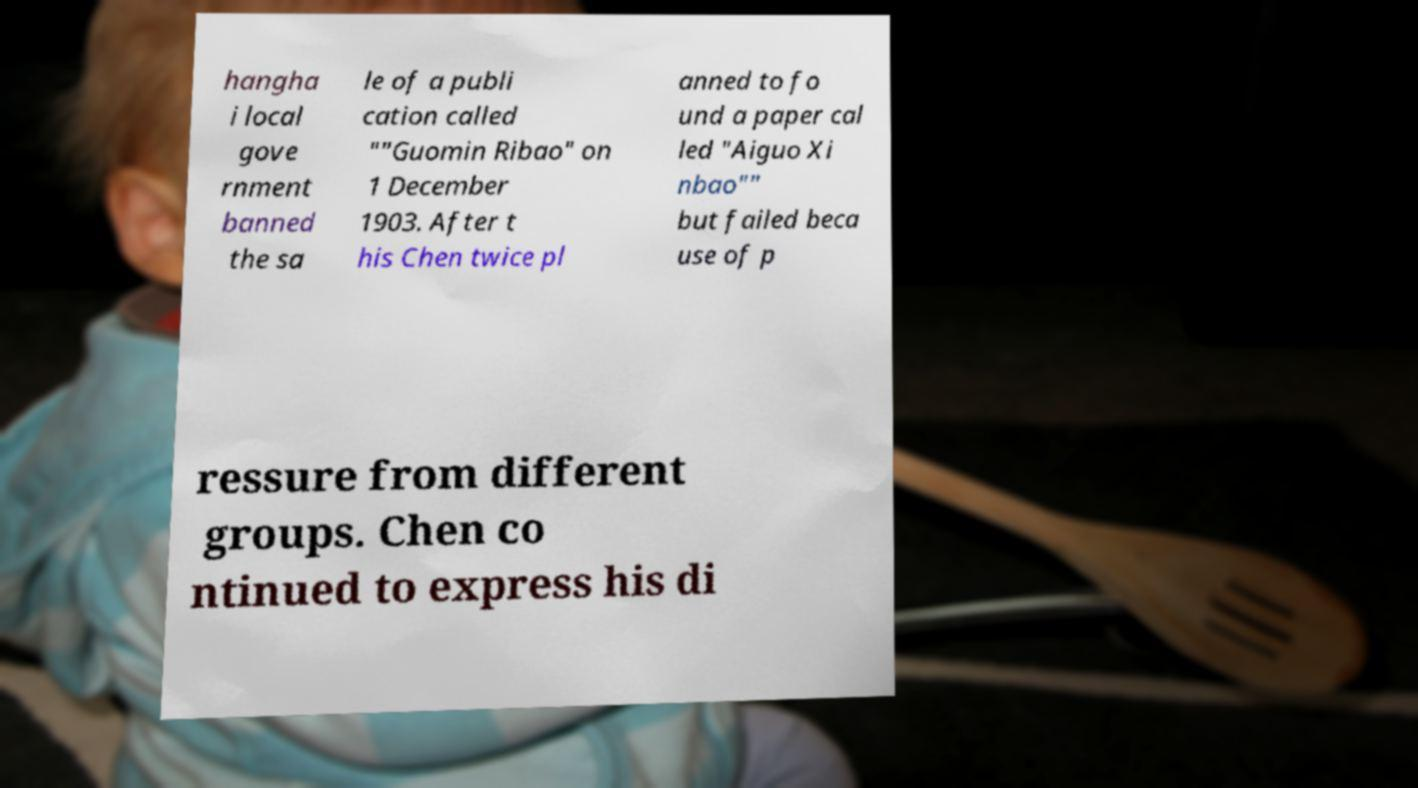Can you read and provide the text displayed in the image?This photo seems to have some interesting text. Can you extract and type it out for me? hangha i local gove rnment banned the sa le of a publi cation called ""Guomin Ribao" on 1 December 1903. After t his Chen twice pl anned to fo und a paper cal led "Aiguo Xi nbao"" but failed beca use of p ressure from different groups. Chen co ntinued to express his di 